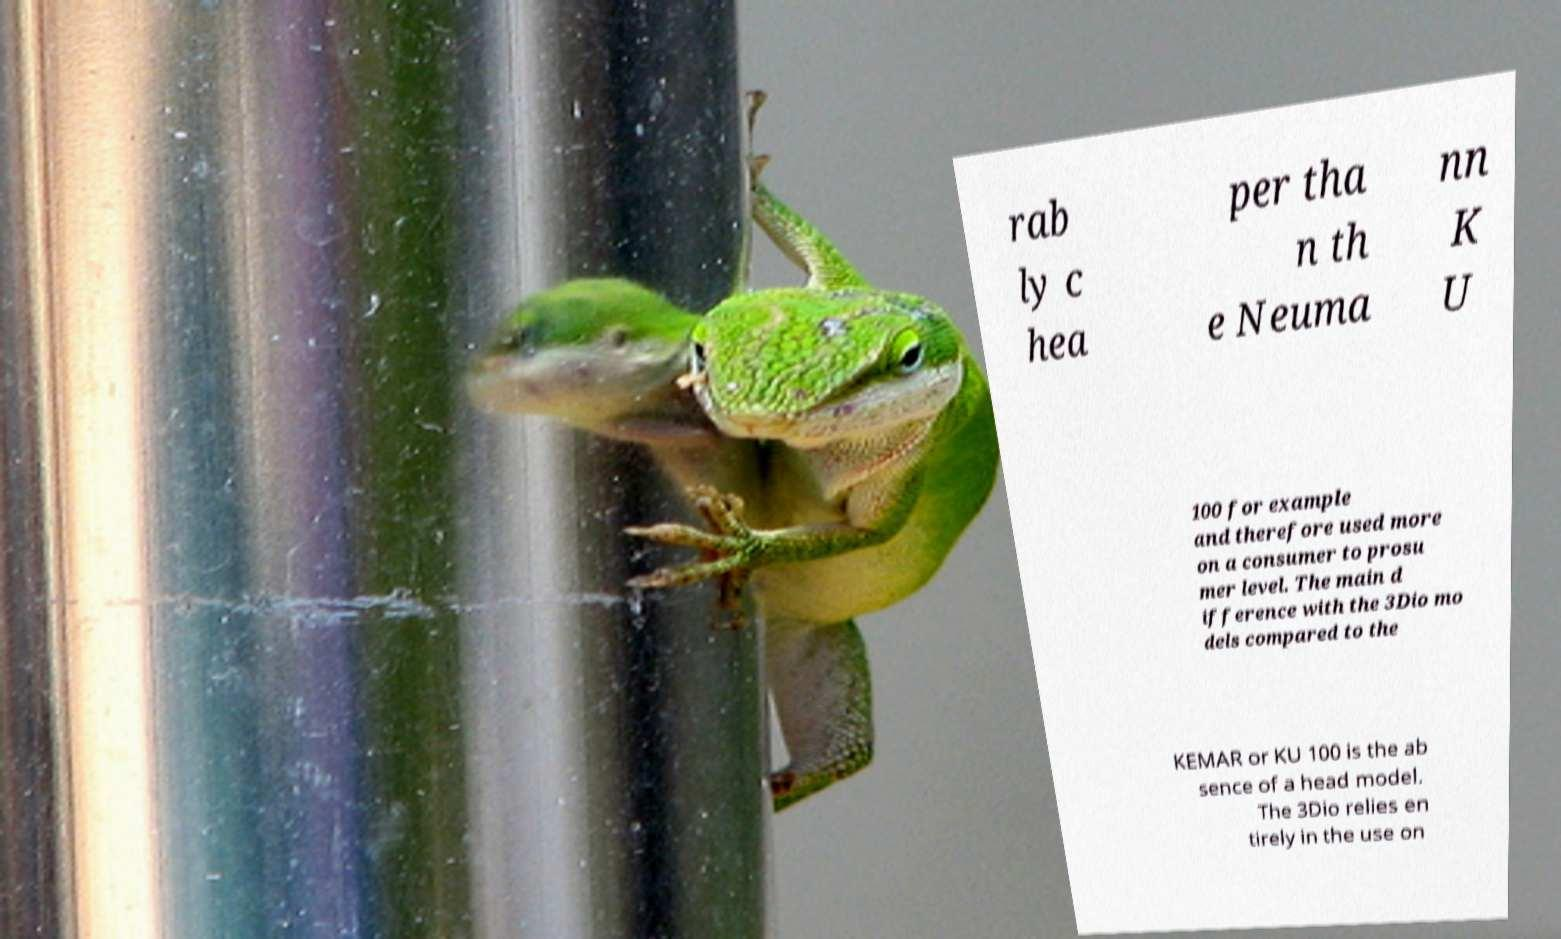I need the written content from this picture converted into text. Can you do that? rab ly c hea per tha n th e Neuma nn K U 100 for example and therefore used more on a consumer to prosu mer level. The main d ifference with the 3Dio mo dels compared to the KEMAR or KU 100 is the ab sence of a head model. The 3Dio relies en tirely in the use on 